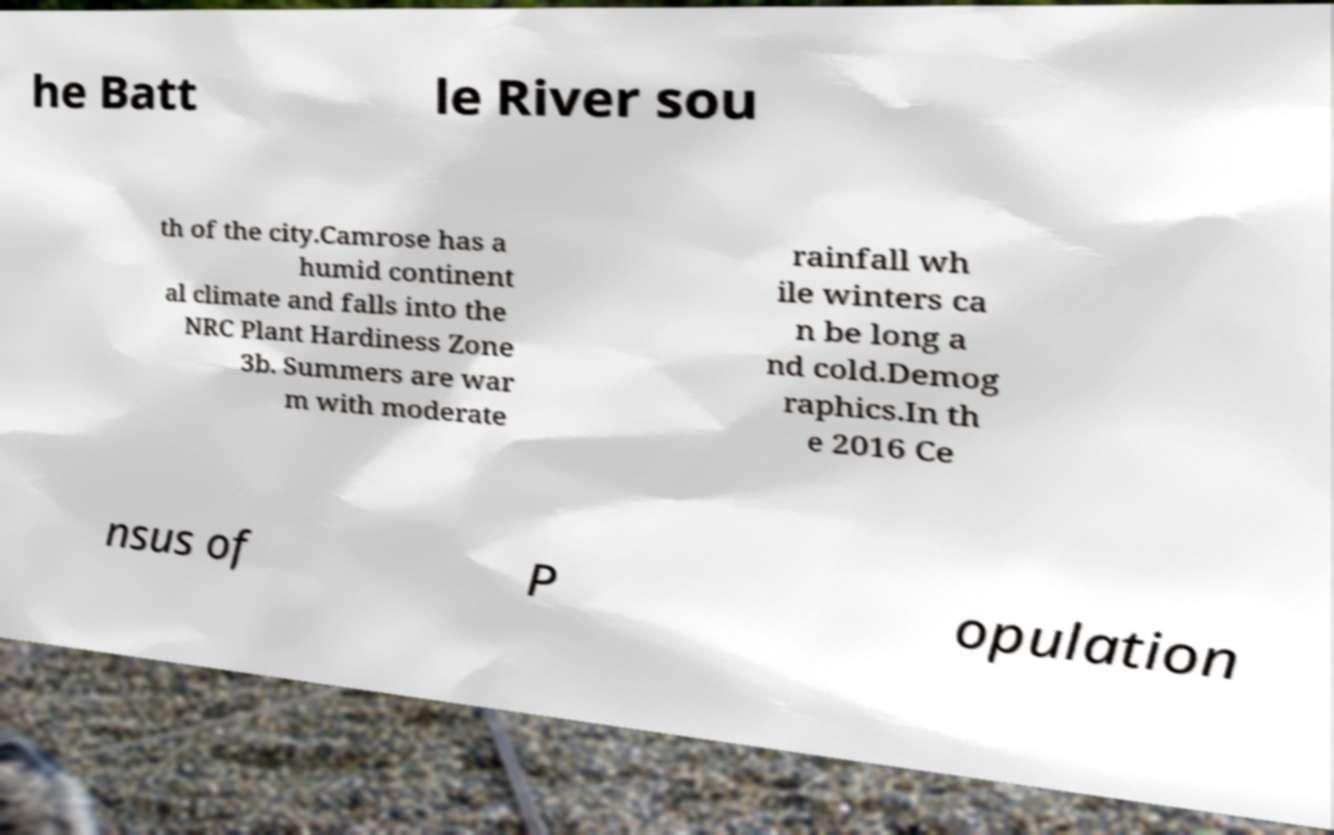Please read and relay the text visible in this image. What does it say? he Batt le River sou th of the city.Camrose has a humid continent al climate and falls into the NRC Plant Hardiness Zone 3b. Summers are war m with moderate rainfall wh ile winters ca n be long a nd cold.Demog raphics.In th e 2016 Ce nsus of P opulation 